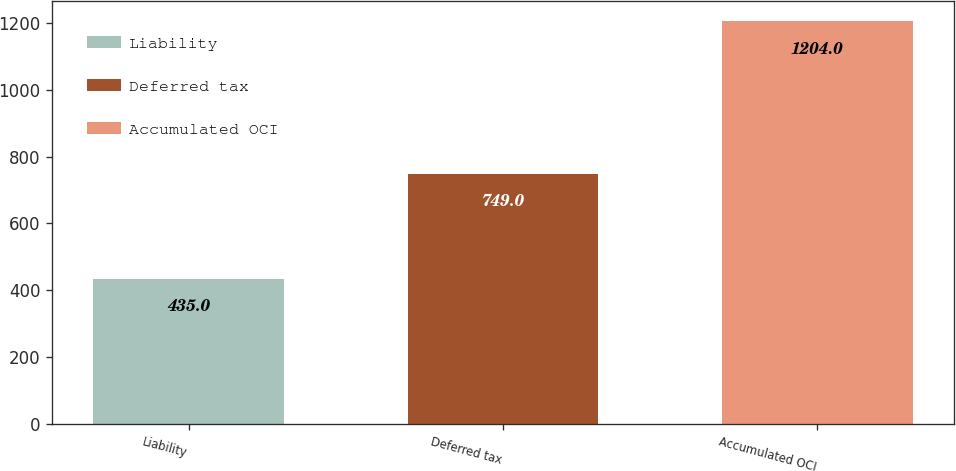Convert chart. <chart><loc_0><loc_0><loc_500><loc_500><bar_chart><fcel>Liability<fcel>Deferred tax<fcel>Accumulated OCI<nl><fcel>435<fcel>749<fcel>1204<nl></chart> 